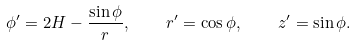Convert formula to latex. <formula><loc_0><loc_0><loc_500><loc_500>\phi ^ { \prime } = 2 H - \frac { \sin \phi } { r } , \quad r ^ { \prime } = \cos \phi , \quad z ^ { \prime } = \sin \phi .</formula> 